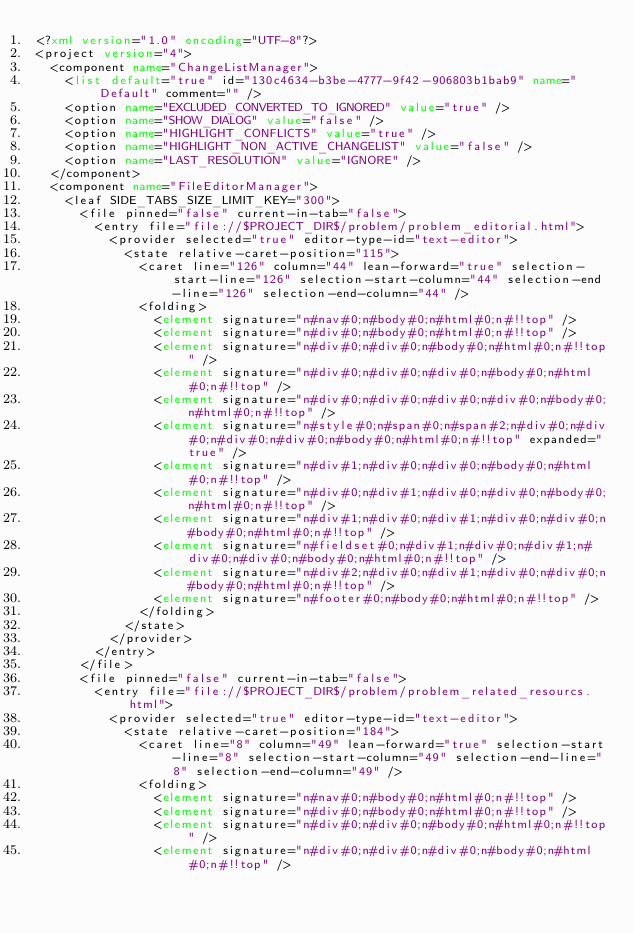Convert code to text. <code><loc_0><loc_0><loc_500><loc_500><_XML_><?xml version="1.0" encoding="UTF-8"?>
<project version="4">
  <component name="ChangeListManager">
    <list default="true" id="130c4634-b3be-4777-9f42-906803b1bab9" name="Default" comment="" />
    <option name="EXCLUDED_CONVERTED_TO_IGNORED" value="true" />
    <option name="SHOW_DIALOG" value="false" />
    <option name="HIGHLIGHT_CONFLICTS" value="true" />
    <option name="HIGHLIGHT_NON_ACTIVE_CHANGELIST" value="false" />
    <option name="LAST_RESOLUTION" value="IGNORE" />
  </component>
  <component name="FileEditorManager">
    <leaf SIDE_TABS_SIZE_LIMIT_KEY="300">
      <file pinned="false" current-in-tab="false">
        <entry file="file://$PROJECT_DIR$/problem/problem_editorial.html">
          <provider selected="true" editor-type-id="text-editor">
            <state relative-caret-position="115">
              <caret line="126" column="44" lean-forward="true" selection-start-line="126" selection-start-column="44" selection-end-line="126" selection-end-column="44" />
              <folding>
                <element signature="n#nav#0;n#body#0;n#html#0;n#!!top" />
                <element signature="n#div#0;n#body#0;n#html#0;n#!!top" />
                <element signature="n#div#0;n#div#0;n#body#0;n#html#0;n#!!top" />
                <element signature="n#div#0;n#div#0;n#div#0;n#body#0;n#html#0;n#!!top" />
                <element signature="n#div#0;n#div#0;n#div#0;n#div#0;n#body#0;n#html#0;n#!!top" />
                <element signature="n#style#0;n#span#0;n#span#2;n#div#0;n#div#0;n#div#0;n#div#0;n#body#0;n#html#0;n#!!top" expanded="true" />
                <element signature="n#div#1;n#div#0;n#div#0;n#body#0;n#html#0;n#!!top" />
                <element signature="n#div#0;n#div#1;n#div#0;n#div#0;n#body#0;n#html#0;n#!!top" />
                <element signature="n#div#1;n#div#0;n#div#1;n#div#0;n#div#0;n#body#0;n#html#0;n#!!top" />
                <element signature="n#fieldset#0;n#div#1;n#div#0;n#div#1;n#div#0;n#div#0;n#body#0;n#html#0;n#!!top" />
                <element signature="n#div#2;n#div#0;n#div#1;n#div#0;n#div#0;n#body#0;n#html#0;n#!!top" />
                <element signature="n#footer#0;n#body#0;n#html#0;n#!!top" />
              </folding>
            </state>
          </provider>
        </entry>
      </file>
      <file pinned="false" current-in-tab="false">
        <entry file="file://$PROJECT_DIR$/problem/problem_related_resourcs.html">
          <provider selected="true" editor-type-id="text-editor">
            <state relative-caret-position="184">
              <caret line="8" column="49" lean-forward="true" selection-start-line="8" selection-start-column="49" selection-end-line="8" selection-end-column="49" />
              <folding>
                <element signature="n#nav#0;n#body#0;n#html#0;n#!!top" />
                <element signature="n#div#0;n#body#0;n#html#0;n#!!top" />
                <element signature="n#div#0;n#div#0;n#body#0;n#html#0;n#!!top" />
                <element signature="n#div#0;n#div#0;n#div#0;n#body#0;n#html#0;n#!!top" /></code> 